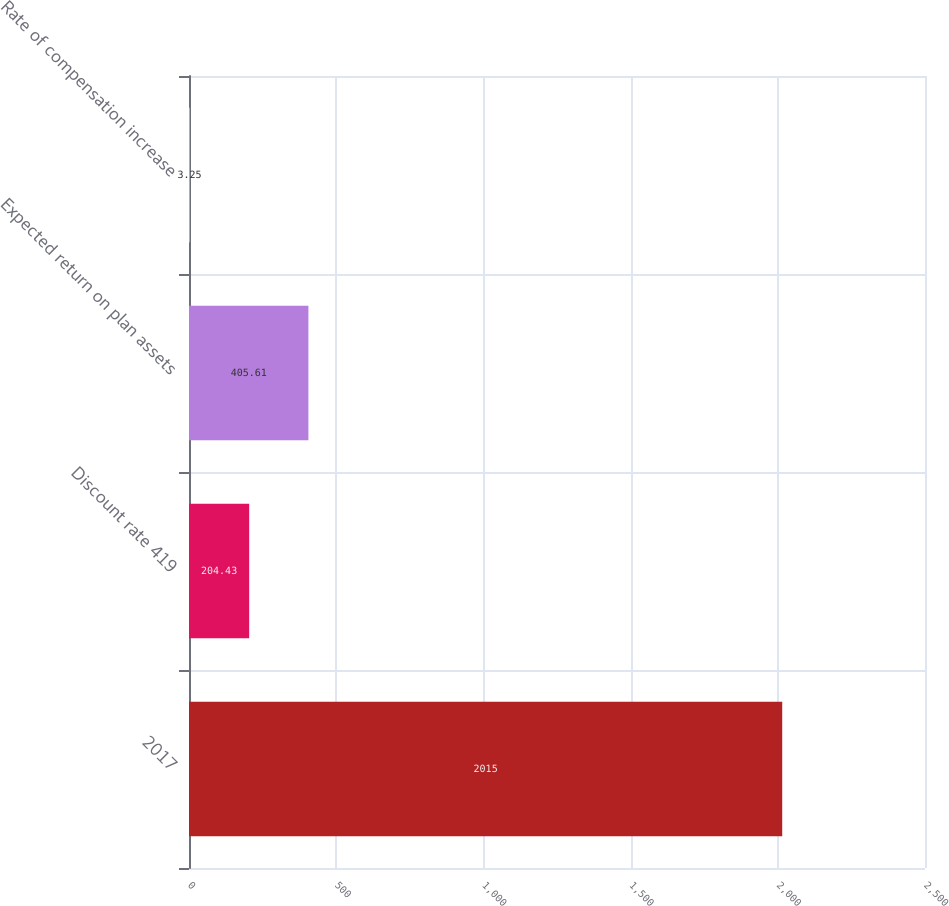Convert chart. <chart><loc_0><loc_0><loc_500><loc_500><bar_chart><fcel>2017<fcel>Discount rate 419<fcel>Expected return on plan assets<fcel>Rate of compensation increase<nl><fcel>2015<fcel>204.43<fcel>405.61<fcel>3.25<nl></chart> 